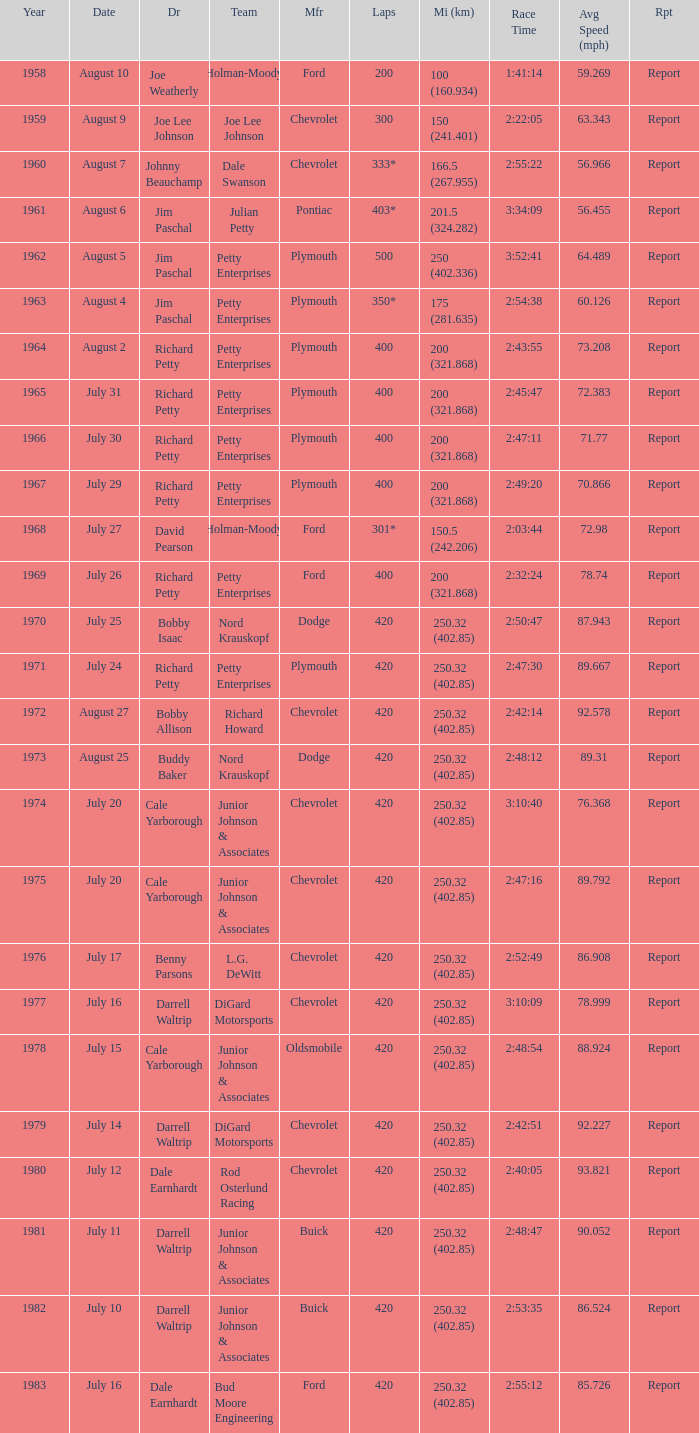I'm looking to parse the entire table for insights. Could you assist me with that? {'header': ['Year', 'Date', 'Dr', 'Team', 'Mfr', 'Laps', 'Mi (km)', 'Race Time', 'Avg Speed (mph)', 'Rpt'], 'rows': [['1958', 'August 10', 'Joe Weatherly', 'Holman-Moody', 'Ford', '200', '100 (160.934)', '1:41:14', '59.269', 'Report'], ['1959', 'August 9', 'Joe Lee Johnson', 'Joe Lee Johnson', 'Chevrolet', '300', '150 (241.401)', '2:22:05', '63.343', 'Report'], ['1960', 'August 7', 'Johnny Beauchamp', 'Dale Swanson', 'Chevrolet', '333*', '166.5 (267.955)', '2:55:22', '56.966', 'Report'], ['1961', 'August 6', 'Jim Paschal', 'Julian Petty', 'Pontiac', '403*', '201.5 (324.282)', '3:34:09', '56.455', 'Report'], ['1962', 'August 5', 'Jim Paschal', 'Petty Enterprises', 'Plymouth', '500', '250 (402.336)', '3:52:41', '64.489', 'Report'], ['1963', 'August 4', 'Jim Paschal', 'Petty Enterprises', 'Plymouth', '350*', '175 (281.635)', '2:54:38', '60.126', 'Report'], ['1964', 'August 2', 'Richard Petty', 'Petty Enterprises', 'Plymouth', '400', '200 (321.868)', '2:43:55', '73.208', 'Report'], ['1965', 'July 31', 'Richard Petty', 'Petty Enterprises', 'Plymouth', '400', '200 (321.868)', '2:45:47', '72.383', 'Report'], ['1966', 'July 30', 'Richard Petty', 'Petty Enterprises', 'Plymouth', '400', '200 (321.868)', '2:47:11', '71.77', 'Report'], ['1967', 'July 29', 'Richard Petty', 'Petty Enterprises', 'Plymouth', '400', '200 (321.868)', '2:49:20', '70.866', 'Report'], ['1968', 'July 27', 'David Pearson', 'Holman-Moody', 'Ford', '301*', '150.5 (242.206)', '2:03:44', '72.98', 'Report'], ['1969', 'July 26', 'Richard Petty', 'Petty Enterprises', 'Ford', '400', '200 (321.868)', '2:32:24', '78.74', 'Report'], ['1970', 'July 25', 'Bobby Isaac', 'Nord Krauskopf', 'Dodge', '420', '250.32 (402.85)', '2:50:47', '87.943', 'Report'], ['1971', 'July 24', 'Richard Petty', 'Petty Enterprises', 'Plymouth', '420', '250.32 (402.85)', '2:47:30', '89.667', 'Report'], ['1972', 'August 27', 'Bobby Allison', 'Richard Howard', 'Chevrolet', '420', '250.32 (402.85)', '2:42:14', '92.578', 'Report'], ['1973', 'August 25', 'Buddy Baker', 'Nord Krauskopf', 'Dodge', '420', '250.32 (402.85)', '2:48:12', '89.31', 'Report'], ['1974', 'July 20', 'Cale Yarborough', 'Junior Johnson & Associates', 'Chevrolet', '420', '250.32 (402.85)', '3:10:40', '76.368', 'Report'], ['1975', 'July 20', 'Cale Yarborough', 'Junior Johnson & Associates', 'Chevrolet', '420', '250.32 (402.85)', '2:47:16', '89.792', 'Report'], ['1976', 'July 17', 'Benny Parsons', 'L.G. DeWitt', 'Chevrolet', '420', '250.32 (402.85)', '2:52:49', '86.908', 'Report'], ['1977', 'July 16', 'Darrell Waltrip', 'DiGard Motorsports', 'Chevrolet', '420', '250.32 (402.85)', '3:10:09', '78.999', 'Report'], ['1978', 'July 15', 'Cale Yarborough', 'Junior Johnson & Associates', 'Oldsmobile', '420', '250.32 (402.85)', '2:48:54', '88.924', 'Report'], ['1979', 'July 14', 'Darrell Waltrip', 'DiGard Motorsports', 'Chevrolet', '420', '250.32 (402.85)', '2:42:51', '92.227', 'Report'], ['1980', 'July 12', 'Dale Earnhardt', 'Rod Osterlund Racing', 'Chevrolet', '420', '250.32 (402.85)', '2:40:05', '93.821', 'Report'], ['1981', 'July 11', 'Darrell Waltrip', 'Junior Johnson & Associates', 'Buick', '420', '250.32 (402.85)', '2:48:47', '90.052', 'Report'], ['1982', 'July 10', 'Darrell Waltrip', 'Junior Johnson & Associates', 'Buick', '420', '250.32 (402.85)', '2:53:35', '86.524', 'Report'], ['1983', 'July 16', 'Dale Earnhardt', 'Bud Moore Engineering', 'Ford', '420', '250.32 (402.85)', '2:55:12', '85.726', 'Report']]} How many races did Cale Yarborough win at an average speed of 88.924 mph? 1.0. 